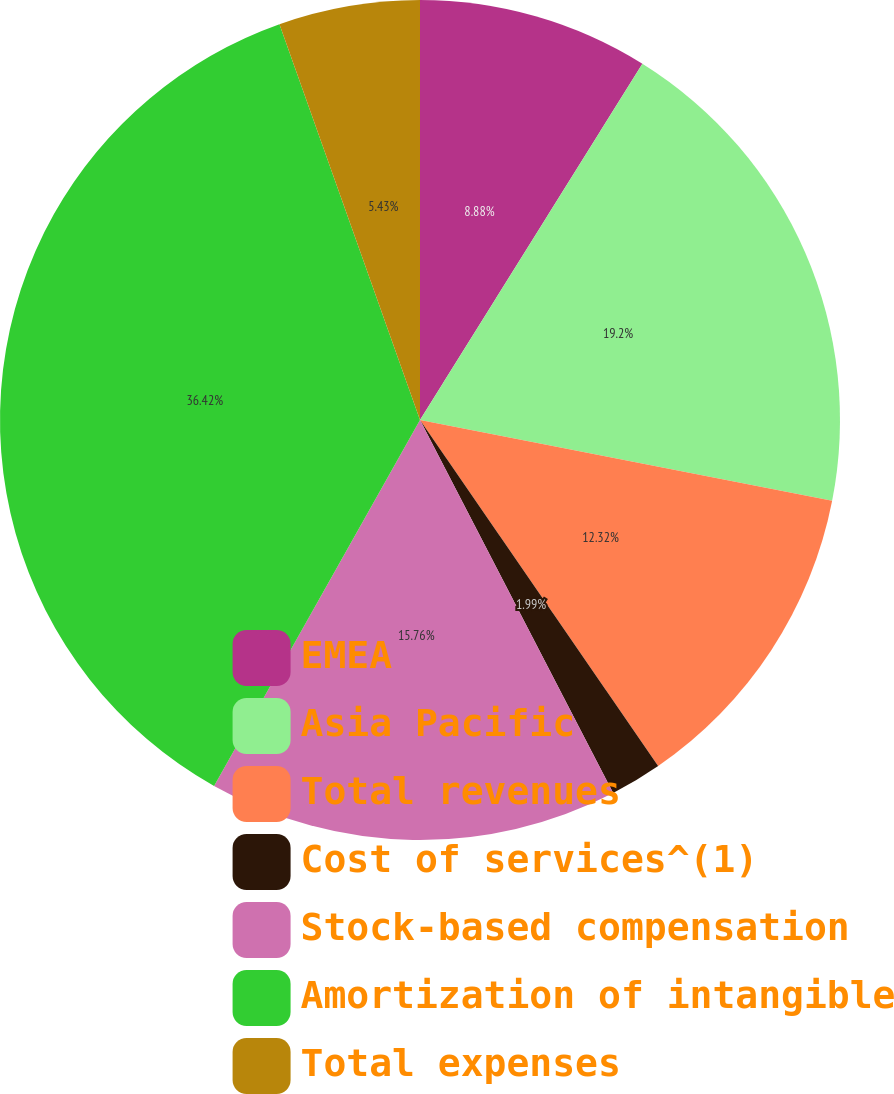Convert chart. <chart><loc_0><loc_0><loc_500><loc_500><pie_chart><fcel>EMEA<fcel>Asia Pacific<fcel>Total revenues<fcel>Cost of services^(1)<fcel>Stock-based compensation<fcel>Amortization of intangible<fcel>Total expenses<nl><fcel>8.88%<fcel>19.2%<fcel>12.32%<fcel>1.99%<fcel>15.76%<fcel>36.41%<fcel>5.43%<nl></chart> 